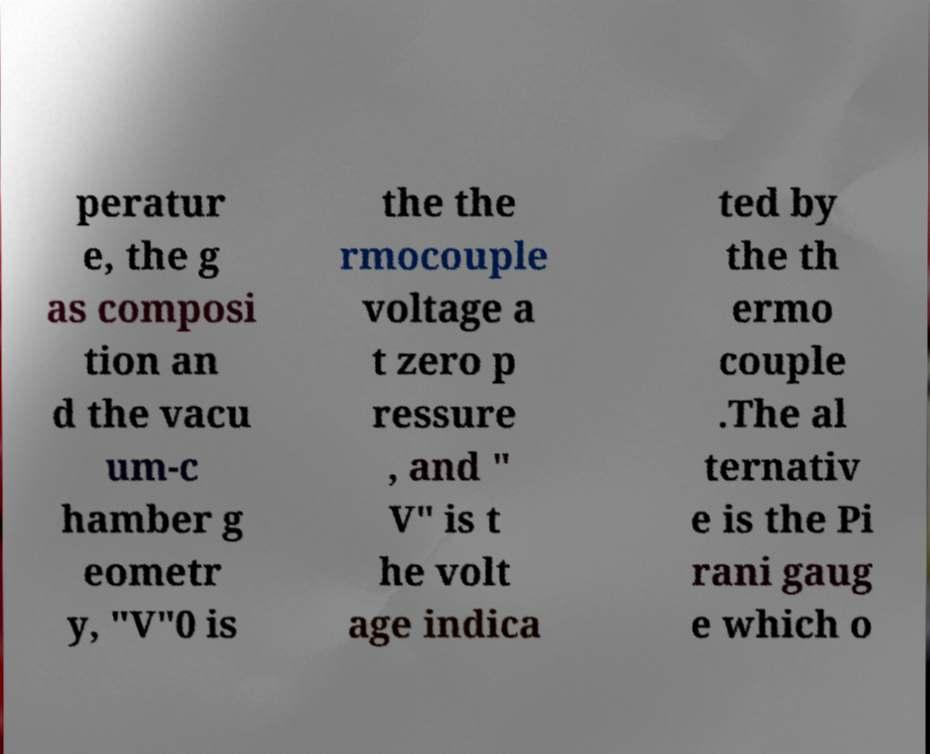Could you extract and type out the text from this image? peratur e, the g as composi tion an d the vacu um-c hamber g eometr y, "V"0 is the the rmocouple voltage a t zero p ressure , and " V" is t he volt age indica ted by the th ermo couple .The al ternativ e is the Pi rani gaug e which o 